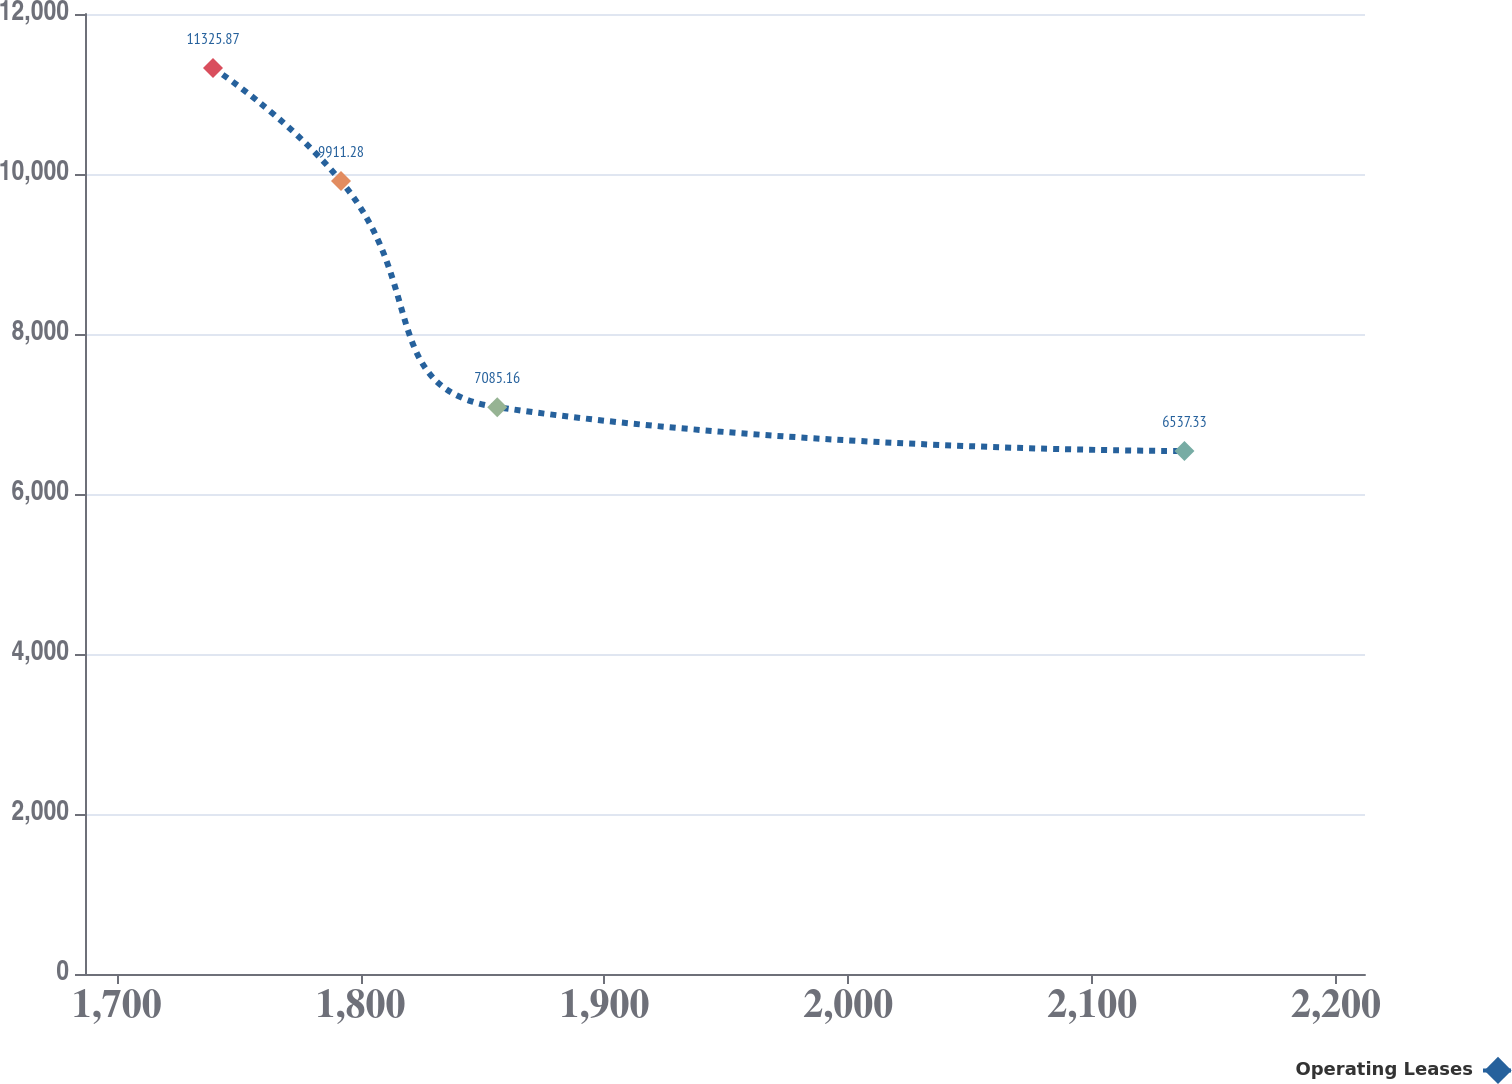<chart> <loc_0><loc_0><loc_500><loc_500><line_chart><ecel><fcel>Operating Leases<nl><fcel>1739.48<fcel>11325.9<nl><fcel>1791.97<fcel>9911.28<nl><fcel>1856.03<fcel>7085.16<nl><fcel>2137.82<fcel>6537.33<nl><fcel>2264.34<fcel>5847.59<nl></chart> 